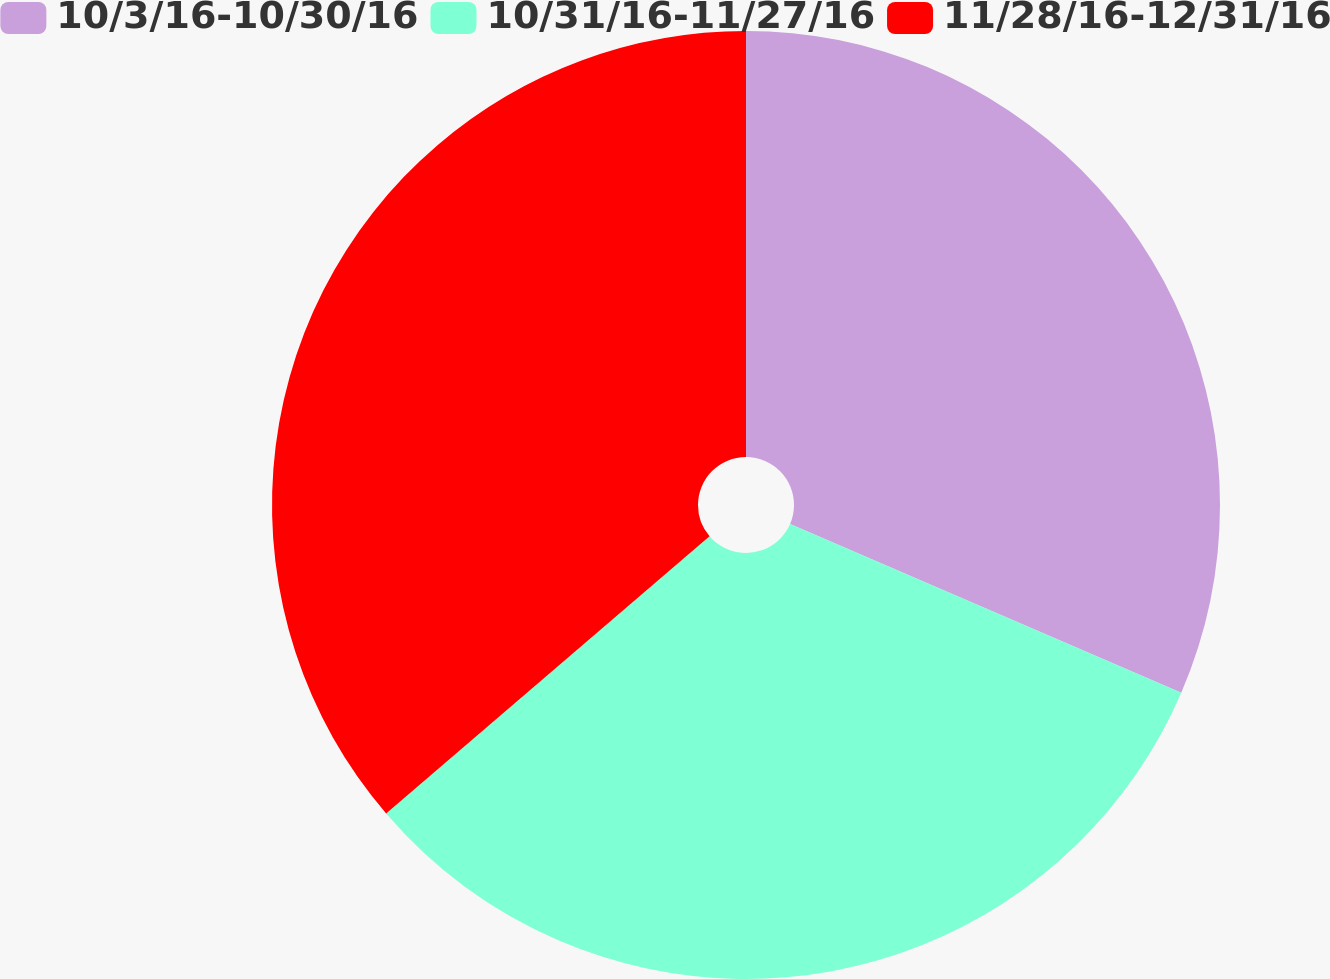Convert chart. <chart><loc_0><loc_0><loc_500><loc_500><pie_chart><fcel>10/3/16-10/30/16<fcel>10/31/16-11/27/16<fcel>11/28/16-12/31/16<nl><fcel>31.48%<fcel>32.24%<fcel>36.28%<nl></chart> 